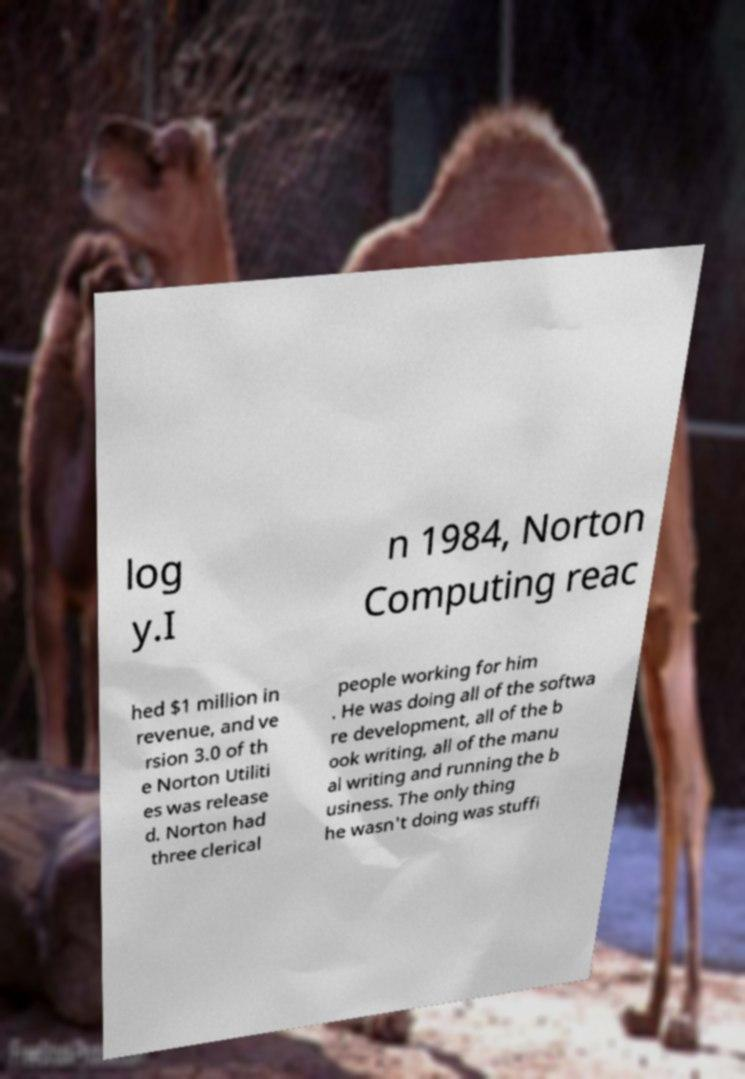Can you accurately transcribe the text from the provided image for me? log y.I n 1984, Norton Computing reac hed $1 million in revenue, and ve rsion 3.0 of th e Norton Utiliti es was release d. Norton had three clerical people working for him . He was doing all of the softwa re development, all of the b ook writing, all of the manu al writing and running the b usiness. The only thing he wasn't doing was stuffi 